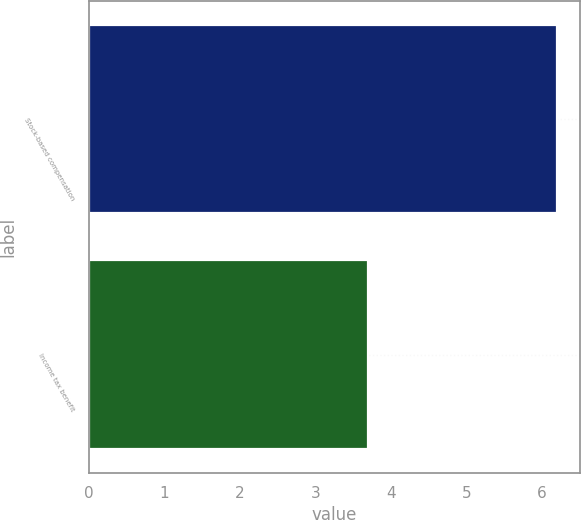<chart> <loc_0><loc_0><loc_500><loc_500><bar_chart><fcel>Stock-based compensation<fcel>Income tax benefit<nl><fcel>6.2<fcel>3.7<nl></chart> 